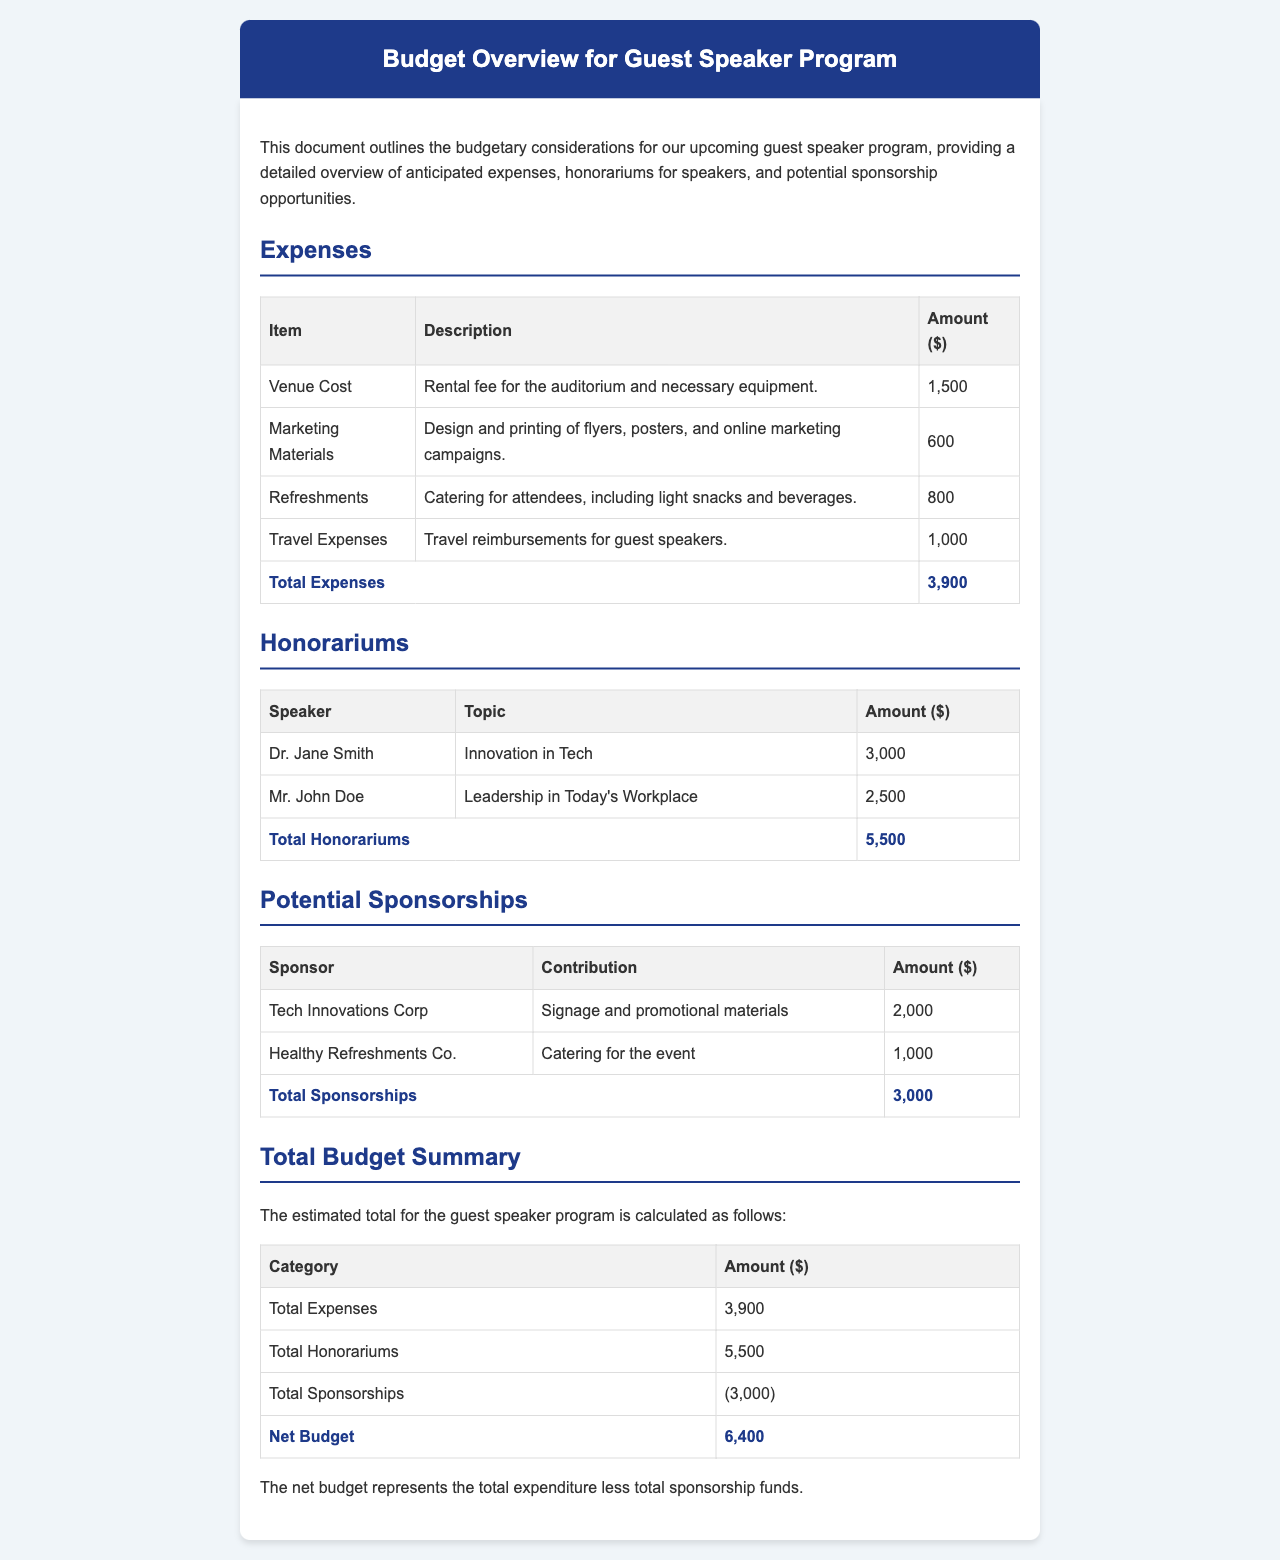What is the total amount for venue cost? The venue cost is listed as $1,500 in the expenses section.
Answer: $1,500 How much is the honorarium for Dr. Jane Smith? The honorarium for Dr. Jane Smith is specified as $3,000 in the honorariums section.
Answer: $3,000 What is the total amount of travel expenses? The total amount for travel expenses is detailed as $1,000 in the expenses section.
Answer: $1,000 What is the total budget for the guest speaker program? The total budget is calculated as total expenses plus total honorariums minus total sponsorships, resulting in $6,400.
Answer: $6,400 How much is Tech Innovations Corp contributing? Tech Innovations Corp is contributing $2,000 as stated in the potential sponsorships section.
Answer: $2,000 What is the total for marketing materials? The total for marketing materials is listed as $600 in the expenses section.
Answer: $600 What is the total for refreshments? The total amount for refreshments is outlined as $800 in the expenses section.
Answer: $800 What is the total honorariums amount? The total honorariums amount is summed up to $5,500 in the honorariums section.
Answer: $5,500 What are the total sponsorships? The total sponsorships amount is indicated as $3,000 in the potential sponsorships section.
Answer: $3,000 